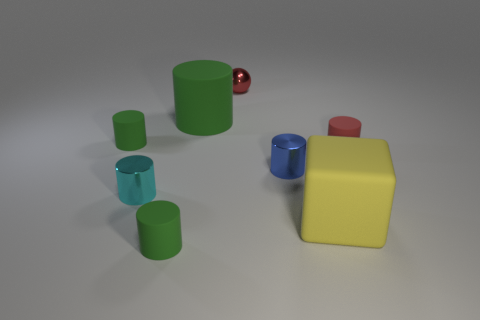Subtract all cyan balls. How many green cylinders are left? 3 Subtract all large matte cylinders. How many cylinders are left? 5 Subtract all red cylinders. How many cylinders are left? 5 Subtract all blue cylinders. Subtract all cyan balls. How many cylinders are left? 5 Add 1 small shiny cylinders. How many objects exist? 9 Subtract all spheres. How many objects are left? 7 Subtract all tiny rubber cylinders. Subtract all red rubber cylinders. How many objects are left? 4 Add 2 big green cylinders. How many big green cylinders are left? 3 Add 5 tiny cyan metal cylinders. How many tiny cyan metal cylinders exist? 6 Subtract 1 cyan cylinders. How many objects are left? 7 